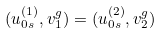<formula> <loc_0><loc_0><loc_500><loc_500>( u _ { 0 s } ^ { ( 1 ) } , v _ { 1 } ^ { g } ) = ( u _ { 0 s } ^ { ( 2 ) } , v _ { 2 } ^ { g } )</formula> 